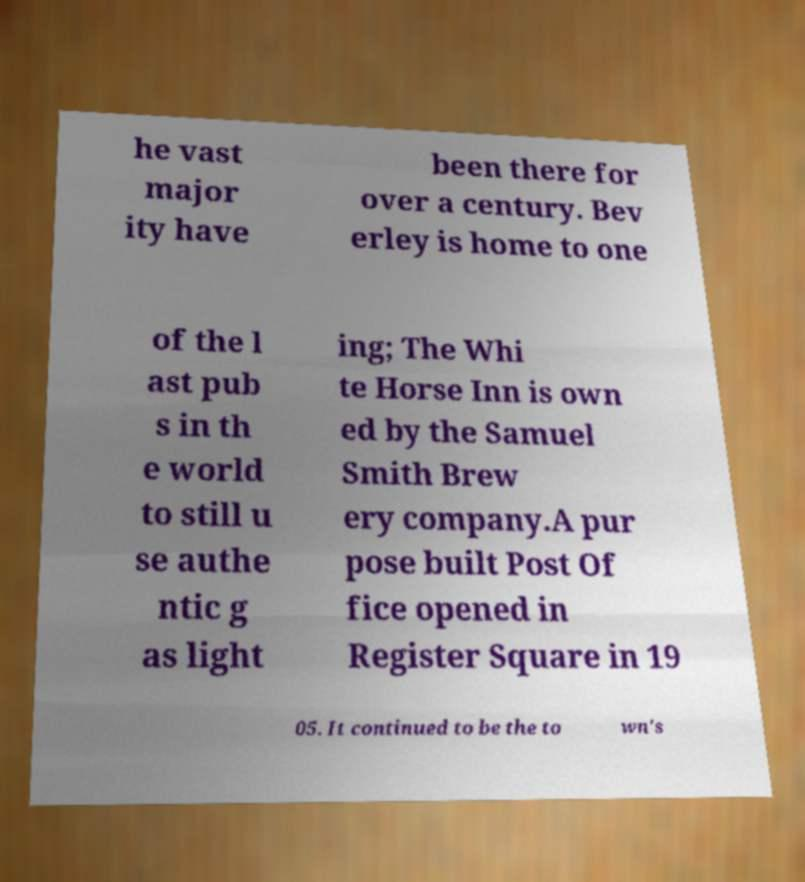For documentation purposes, I need the text within this image transcribed. Could you provide that? he vast major ity have been there for over a century. Bev erley is home to one of the l ast pub s in th e world to still u se authe ntic g as light ing; The Whi te Horse Inn is own ed by the Samuel Smith Brew ery company.A pur pose built Post Of fice opened in Register Square in 19 05. It continued to be the to wn's 